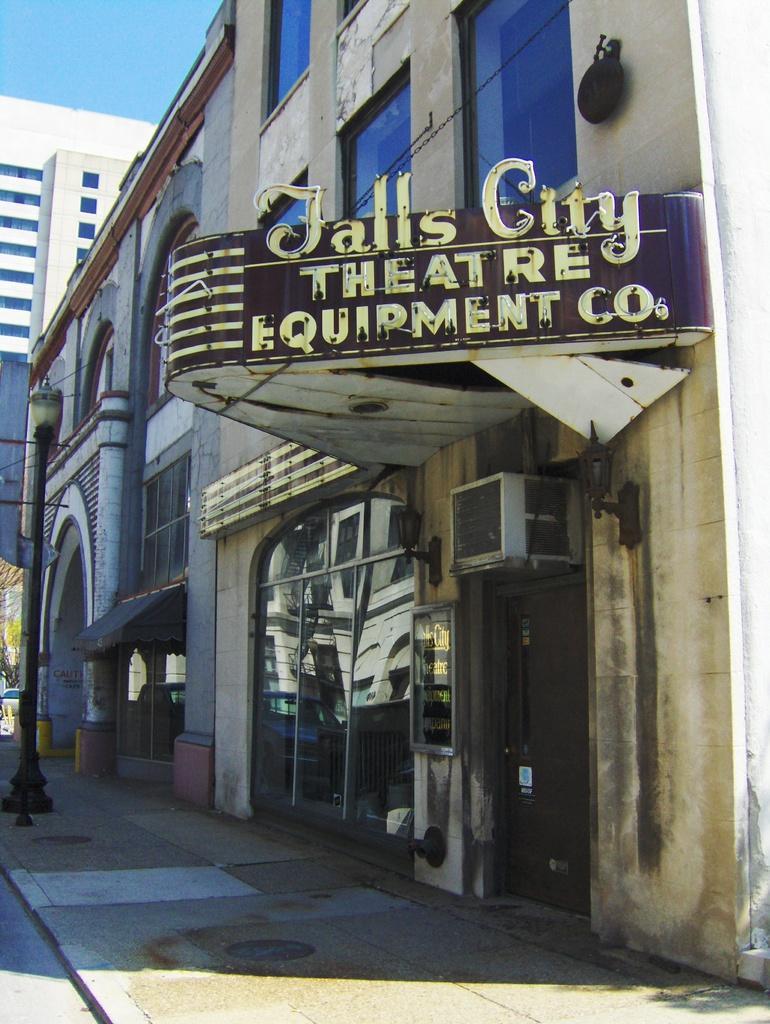In one or two sentences, can you explain what this image depicts? In this picture I can see the board in the middle, there are buildings. On the left side there is the street lamp and at the top I can see the sky. 